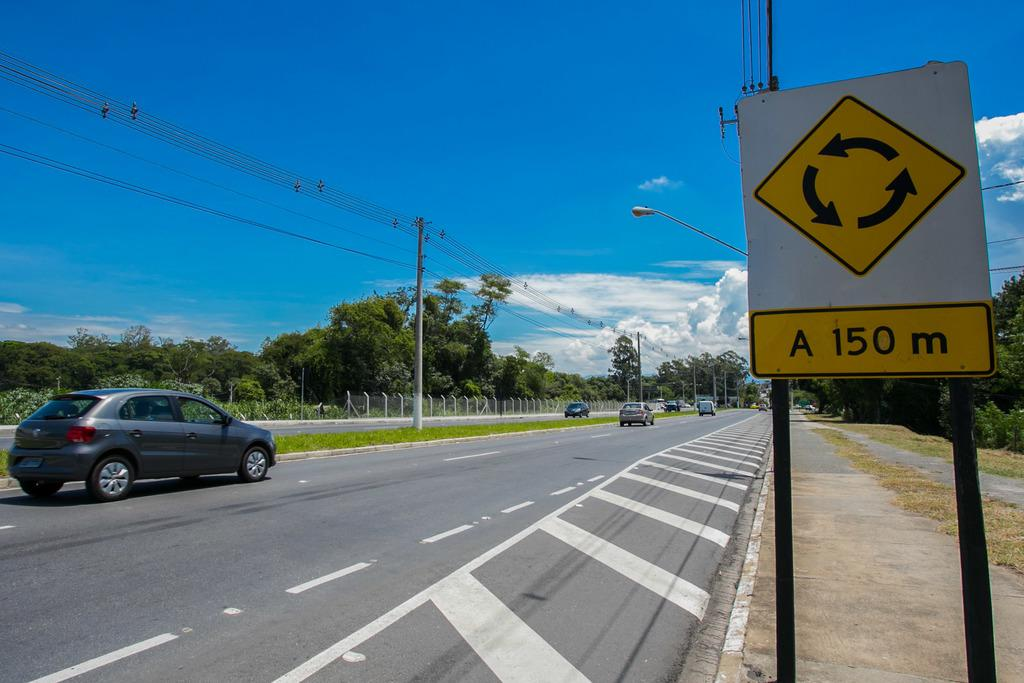<image>
Present a compact description of the photo's key features. a 150 m sign that is outside in daytime 